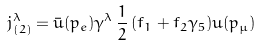Convert formula to latex. <formula><loc_0><loc_0><loc_500><loc_500>j ^ { \lambda } _ { ( 2 ) } = { \bar { u } } ( p _ { e } ) \gamma ^ { \lambda } \, { \frac { 1 } { 2 } } \, ( f _ { 1 } + f _ { 2 } \gamma _ { 5 } ) u ( p _ { \mu } )</formula> 